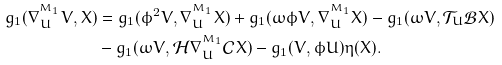<formula> <loc_0><loc_0><loc_500><loc_500>g _ { 1 } ( \nabla ^ { ^ { M _ { 1 } } } _ { U } V , X ) & = g _ { 1 } ( \phi ^ { 2 } V , \nabla ^ { ^ { M _ { 1 } } } _ { U } X ) + g _ { 1 } ( \omega \phi V , \nabla ^ { ^ { M _ { 1 } } } _ { U } X ) - g _ { 1 } ( \omega V , \mathcal { T } _ { U } \mathcal { B } X ) \\ & - g _ { 1 } ( \omega V , \mathcal { H } \nabla ^ { ^ { M _ { 1 } } } _ { U } \mathcal { C } X ) - g _ { 1 } ( V , \phi U ) \eta ( X ) .</formula> 